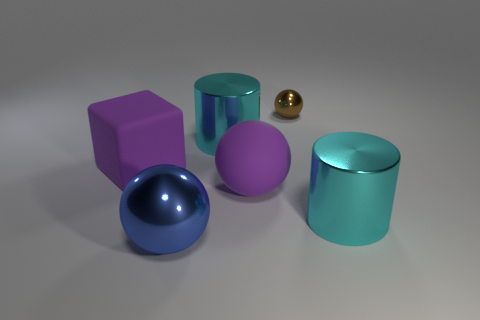Add 1 big purple rubber cubes. How many objects exist? 7 Subtract all cylinders. How many objects are left? 4 Add 4 matte balls. How many matte balls are left? 5 Add 6 large matte balls. How many large matte balls exist? 7 Subtract 0 red cylinders. How many objects are left? 6 Subtract all large gray rubber cubes. Subtract all matte objects. How many objects are left? 4 